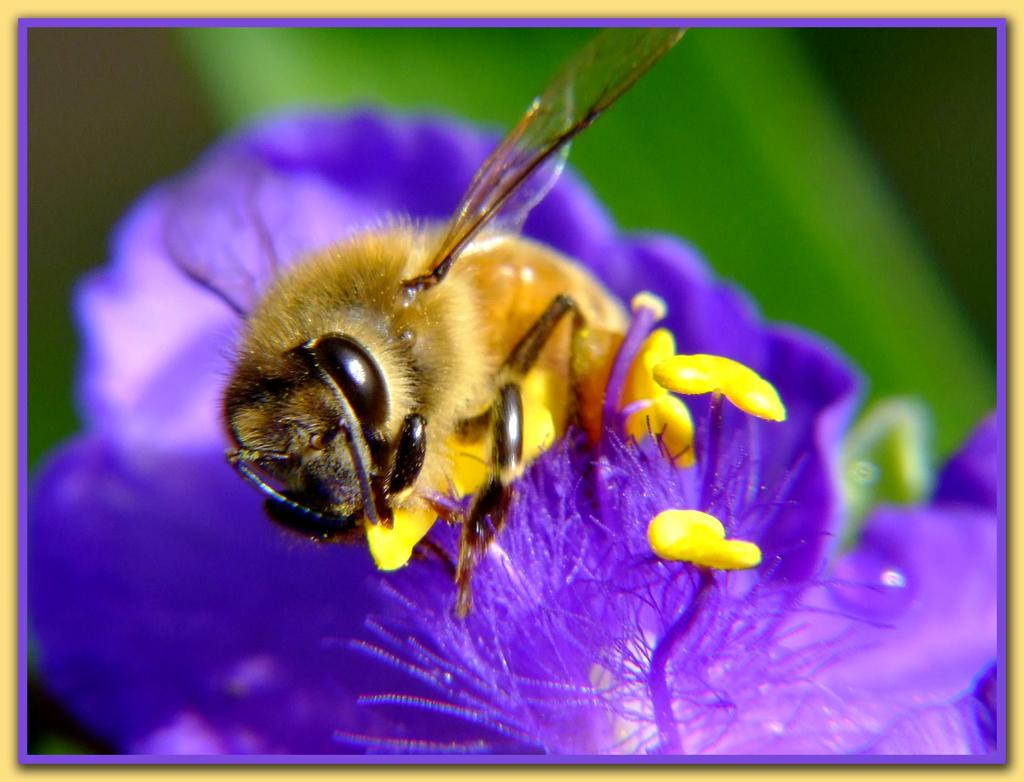What is present in the image? There is an insect in the image. Where is the insect located? The insect is on a flower. What is the position of the insect and flower in the image? The insect and flower are in the center of the image. What type of coil is being used by the insect in the image? There is no coil present in the image; it features an insect on a flower. Is there a seat visible in the image? No, there is no seat present in the image. 